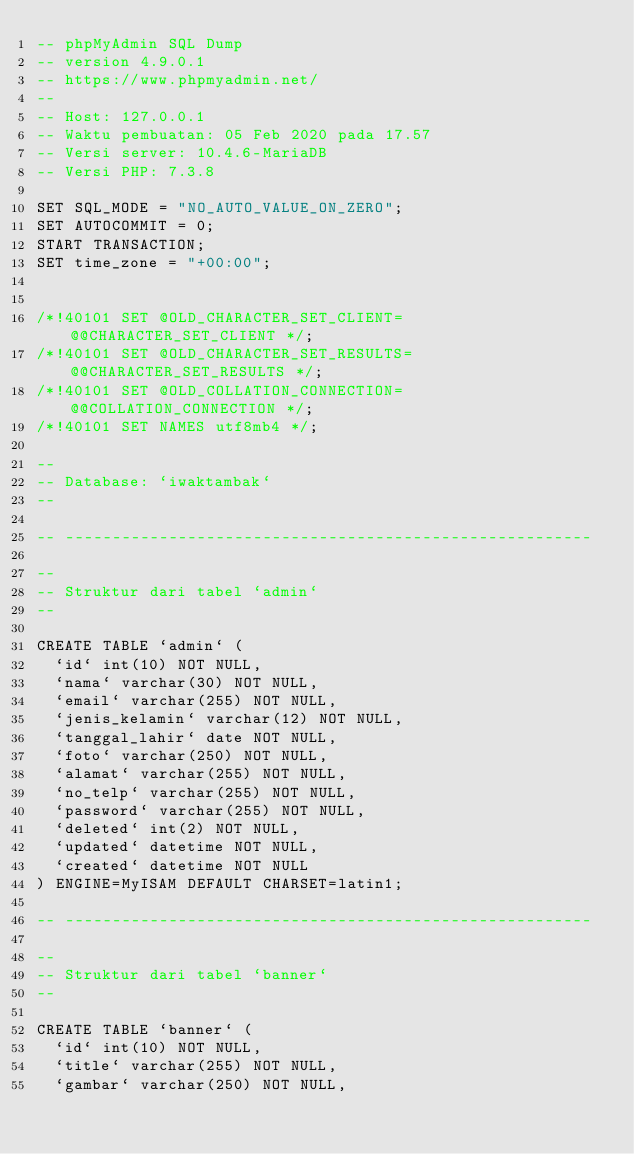<code> <loc_0><loc_0><loc_500><loc_500><_SQL_>-- phpMyAdmin SQL Dump
-- version 4.9.0.1
-- https://www.phpmyadmin.net/
--
-- Host: 127.0.0.1
-- Waktu pembuatan: 05 Feb 2020 pada 17.57
-- Versi server: 10.4.6-MariaDB
-- Versi PHP: 7.3.8

SET SQL_MODE = "NO_AUTO_VALUE_ON_ZERO";
SET AUTOCOMMIT = 0;
START TRANSACTION;
SET time_zone = "+00:00";


/*!40101 SET @OLD_CHARACTER_SET_CLIENT=@@CHARACTER_SET_CLIENT */;
/*!40101 SET @OLD_CHARACTER_SET_RESULTS=@@CHARACTER_SET_RESULTS */;
/*!40101 SET @OLD_COLLATION_CONNECTION=@@COLLATION_CONNECTION */;
/*!40101 SET NAMES utf8mb4 */;

--
-- Database: `iwaktambak`
--

-- --------------------------------------------------------

--
-- Struktur dari tabel `admin`
--

CREATE TABLE `admin` (
  `id` int(10) NOT NULL,
  `nama` varchar(30) NOT NULL,
  `email` varchar(255) NOT NULL,
  `jenis_kelamin` varchar(12) NOT NULL,
  `tanggal_lahir` date NOT NULL,
  `foto` varchar(250) NOT NULL,
  `alamat` varchar(255) NOT NULL,
  `no_telp` varchar(255) NOT NULL,
  `password` varchar(255) NOT NULL,
  `deleted` int(2) NOT NULL,
  `updated` datetime NOT NULL,
  `created` datetime NOT NULL
) ENGINE=MyISAM DEFAULT CHARSET=latin1;

-- --------------------------------------------------------

--
-- Struktur dari tabel `banner`
--

CREATE TABLE `banner` (
  `id` int(10) NOT NULL,
  `title` varchar(255) NOT NULL,
  `gambar` varchar(250) NOT NULL,</code> 